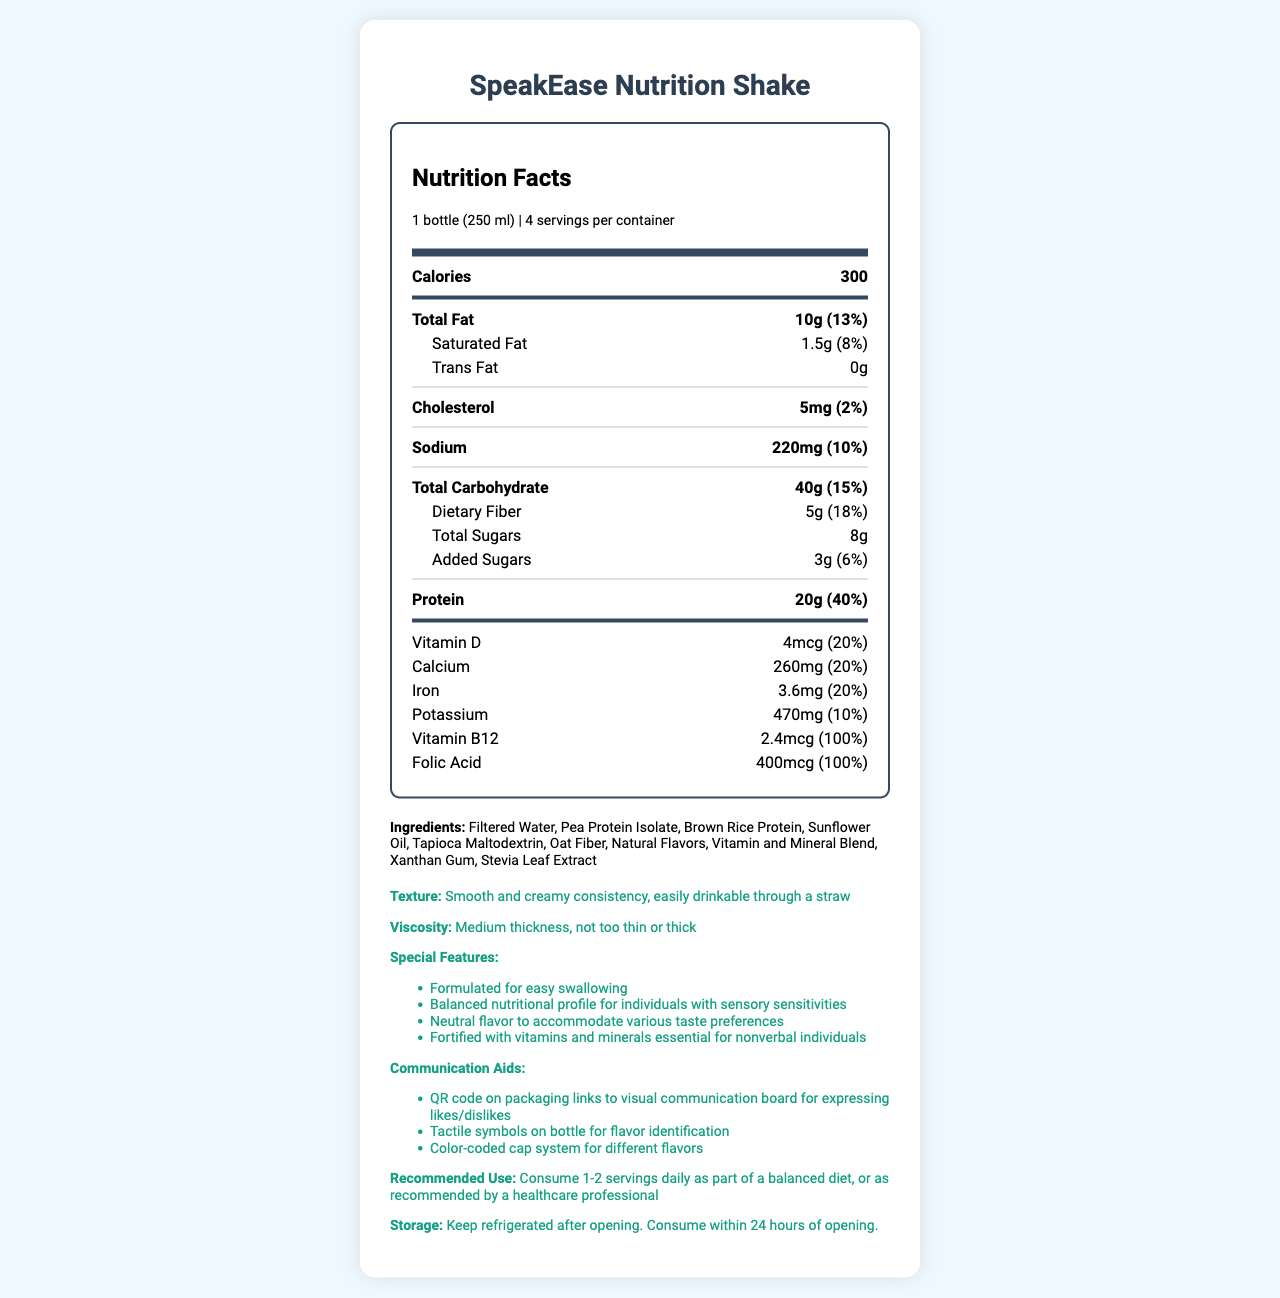what is the product name? The product name is clearly mentioned at the top of the document and in the title.
Answer: SpeakEase Nutrition Shake how many servings are in one container? The document states "4 servings per container" in the serving information.
Answer: 4 servings per container how many calories are in one serving? The calories per serving are shown in the nutrition label under "Calories".
Answer: 300 calories what is the total fat content in one serving? The "Total Fat" amount is listed as 10g with a daily value of 13% in the nutrition label.
Answer: 10g (13%) what are the main ingredients in the shake? The main ingredients are listed in the ingredients section of the document.
Answer: Filtered Water, Pea Protein Isolate, Brown Rice Protein, Sunflower Oil, Tapioca Maltodextrin, Oat Fiber, Natural Flavors, Vitamin and Mineral Blend, Xanthan Gum, Stevia Leaf Extract which vitamin has 100% daily value per serving? A. Vitamin D B. Calcium C. Vitamin B12 D. Folic Acid The nutrition label specifies that Vitamin B12 has a daily value of 100%.
Answer: C. Vitamin B12 what is the cholesterol content in one serving? A. 5mg B. 10mg C. 20mg The cholesterol content is listed as 5mg in one serving.
Answer: A. 5mg is this product suitable for individuals with major allergies? The allergen information states "Contains: None of the major allergens".
Answer: Yes does this shake have added sugars? The nutrition label shows "Added Sugars" with an amount of 3g (6% daily value).
Answer: Yes describe the texture and consistency information provided for the shake. The texture information section describes these characteristics.
Answer: Smooth and creamy consistency, easily drinkable through a straw; Medium thickness, not too thin or thick what special features make this product suitable for nonverbal individuals? These features are listed in the special features section.
Answer: Formulated for easy swallowing, Balanced nutritional profile for individuals with sensory sensitivities, Neutral flavor to accommodate various taste preferences, Fortified with vitamins and minerals essential for nonverbal individuals Can the exact price of the product be determined from the document? The document does not provide any information regarding the price of the product.
Answer: Cannot be determined does the document recommend a specific number of servings per day? The recommended use section suggests consuming 1-2 servings daily as part of a balanced diet, or as recommended by a healthcare professional.
Answer: Yes provide a summary of the document. The summary covers the main points including the product name, nutritional information, special features, and additional instructions provided in the document.
Answer: The document is a customized Nutrition Facts label for "SpeakEase Nutrition Shake" designed specifically for nonverbal individuals with specific dietary needs. It outlines the nutritional content, ingredients, allergens, and special features of the product, including texture and consistency information, special features for easy consumption and communication aids, and recommended use and storage instructions. 